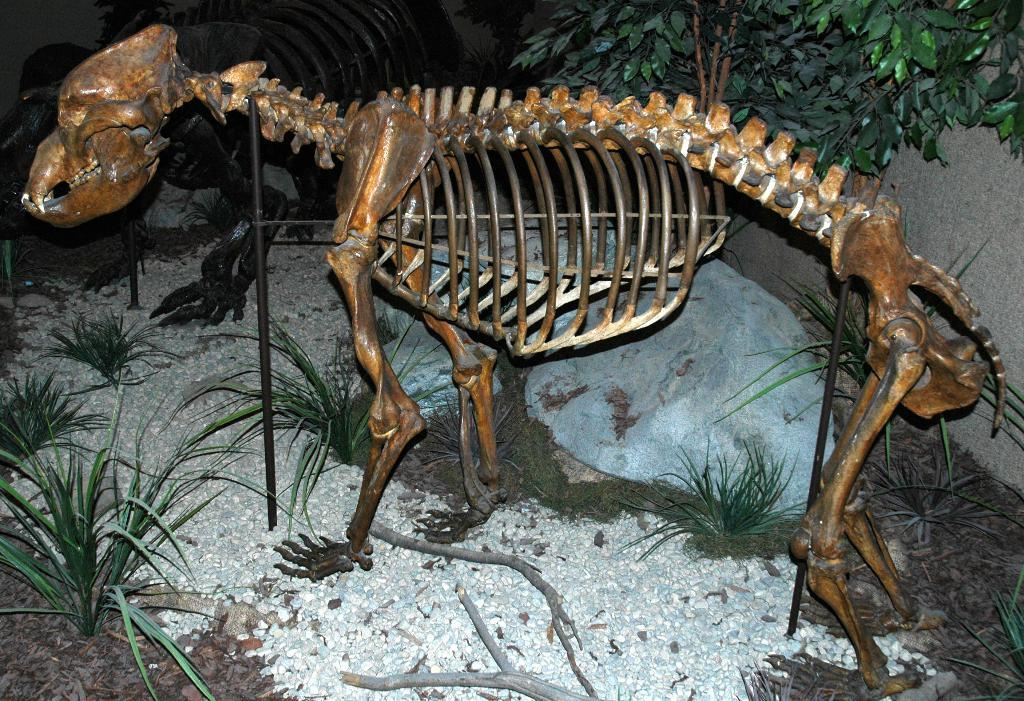What is the main subject of the image? There is a skeleton of an animal in the image. What type of vegetation can be seen in the image? There is grass visible in the image. What is on the ground in the image? Small stones are present on the ground. What can be seen in the background of the image? There are small trees in the background of the image. What type of sail can be seen on the animal's skeleton in the image? There is no sail present on the animal's skeleton in the image. 